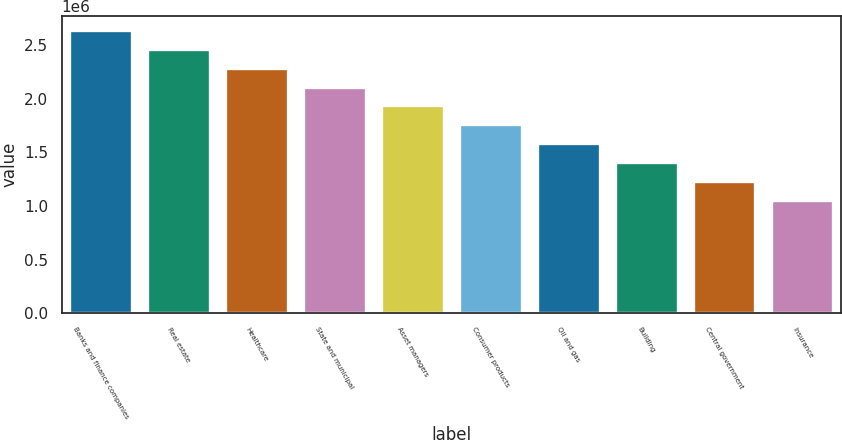<chart> <loc_0><loc_0><loc_500><loc_500><bar_chart><fcel>Banks and finance companies<fcel>Real estate<fcel>Healthcare<fcel>State and municipal<fcel>Asset managers<fcel>Consumer products<fcel>Oil and gas<fcel>Building<fcel>Central government<fcel>Insurance<nl><fcel>2.6389e+06<fcel>2.46336e+06<fcel>2.28781e+06<fcel>2.11227e+06<fcel>1.93672e+06<fcel>1.76118e+06<fcel>1.58564e+06<fcel>1.41009e+06<fcel>1.23455e+06<fcel>1.059e+06<nl></chart> 